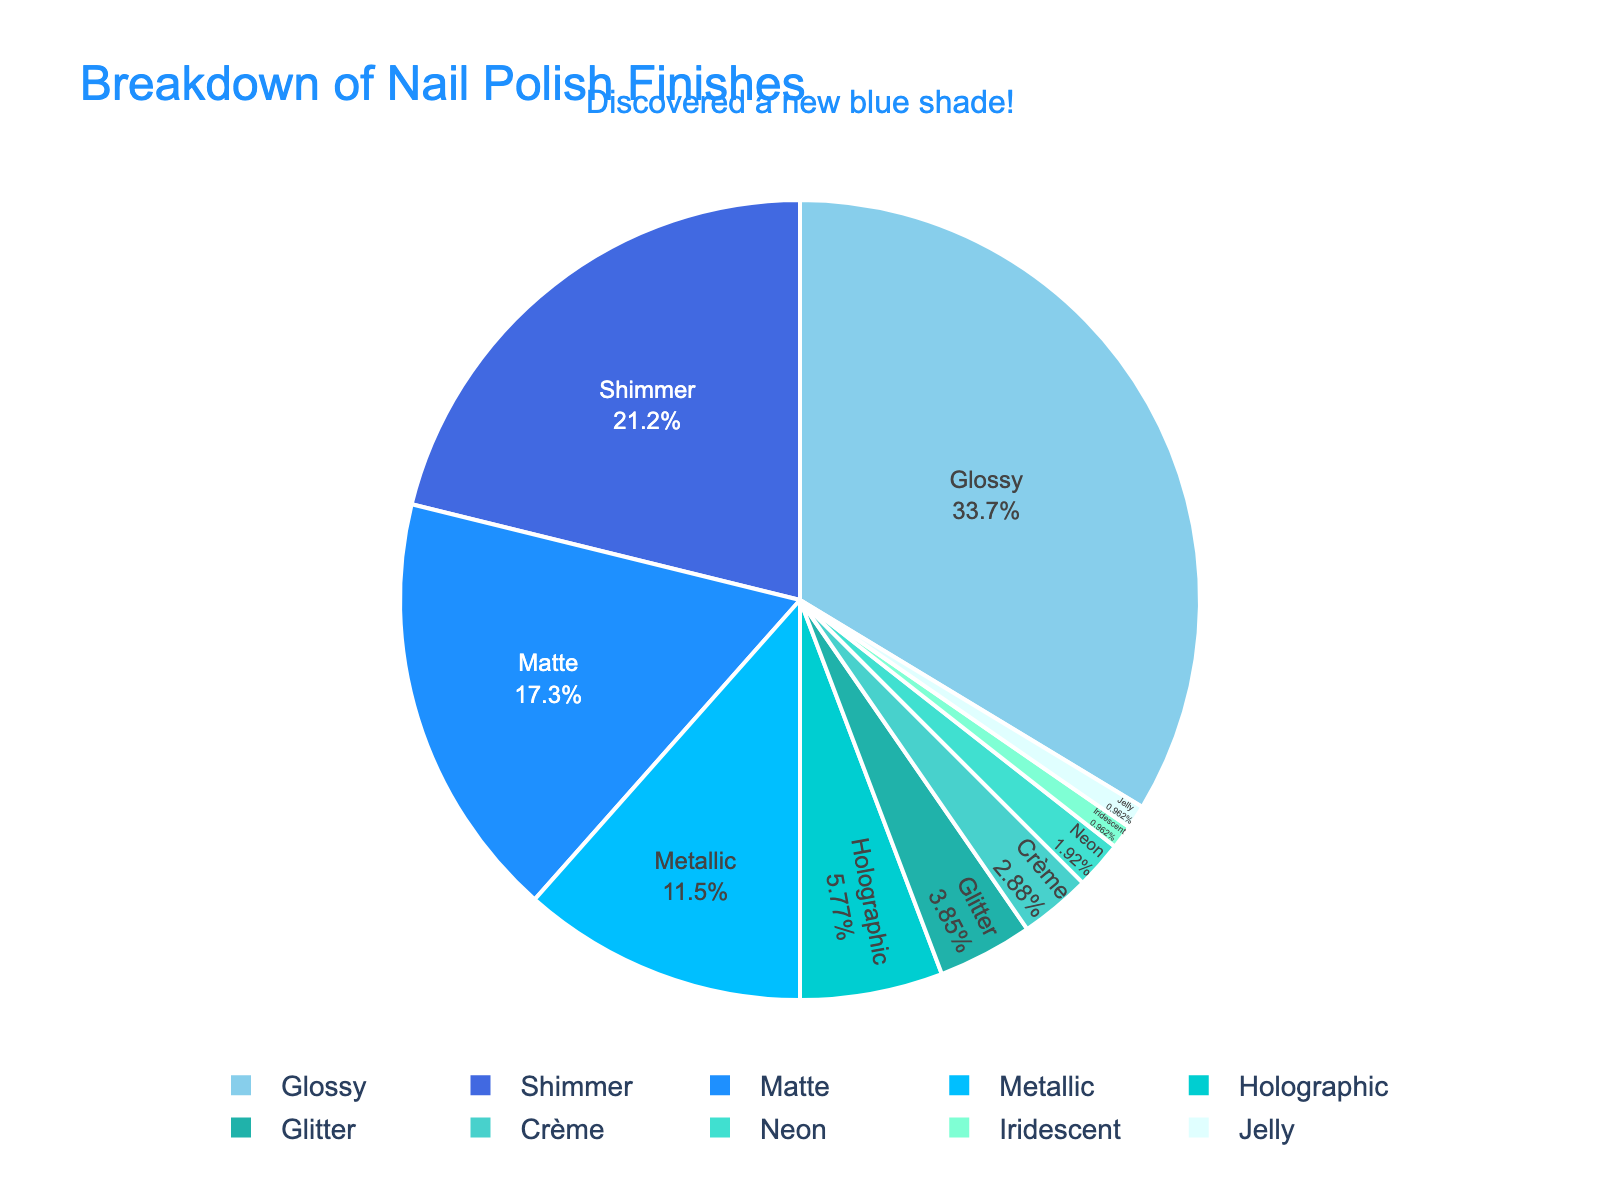Which nail polish finish is the most preferred by consumers? To find the most preferred finish, look at the largest slice in the pie chart. The largest slice corresponds to the finish with the highest percentage.
Answer: Glossy Which nail polish finish is the least preferred by consumers? To find the least preferred finish, identify the smallest slice in the pie chart. The smallest slice corresponds to the finish with the lowest percentage.
Answer: Iridescent and Jelly How many nail polish finishes have a preference percentage higher than 20%? First, identify each sector's percentage in the pie chart and count those that are higher than 20%. According to the chart, Glossy and Shimmer have percentages of 35% and 22%, respectively.
Answer: 2 What is the combined percentage of consumers who prefer Matte and Metallic finishes? Locate the percentage for Matte (18%) and Metallic (12%) in the pie chart, and then sum them up. The computation is 18% + 12% = 30%.
Answer: 30% Is the preference for Glossy finishes greater than the combined preference for Matte and Metallic finishes? Compare the percentage for Glossy (35%) with the combined percentage for Matte and Metallic (18% + 12% = 30%). Since 35% is greater than 30%, the answer is yes.
Answer: Yes Which three finishes are the least preferred by consumers? Identify the three smallest slices in the pie chart. According to the chart, Iridescent (1%), Jelly (1%), and Neon (2%) are the least preferred.
Answer: Iridescent, Jelly, Neon By how much does the preference for Glossy finishes exceed the preference for Holographic finishes? Subtract the percentage of Holographic finishes (6%) from the percentage of Glossy finishes (35%). The calculation is 35% - 6% = 29%.
Answer: 29% Which color in the pie chart represents the Shimmer finish? Find the section labeled "Shimmer" and observe the color used. The Shimmer section corresponds to a specific blue color in the chart.
Answer: Darker Blue 